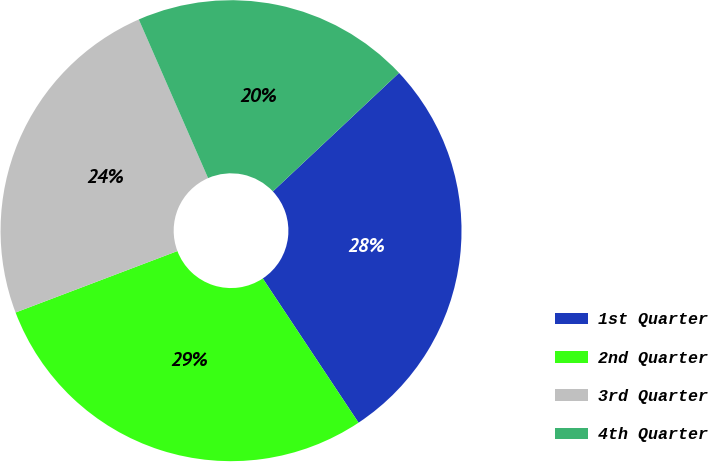<chart> <loc_0><loc_0><loc_500><loc_500><pie_chart><fcel>1st Quarter<fcel>2nd Quarter<fcel>3rd Quarter<fcel>4th Quarter<nl><fcel>27.67%<fcel>28.55%<fcel>24.22%<fcel>19.55%<nl></chart> 